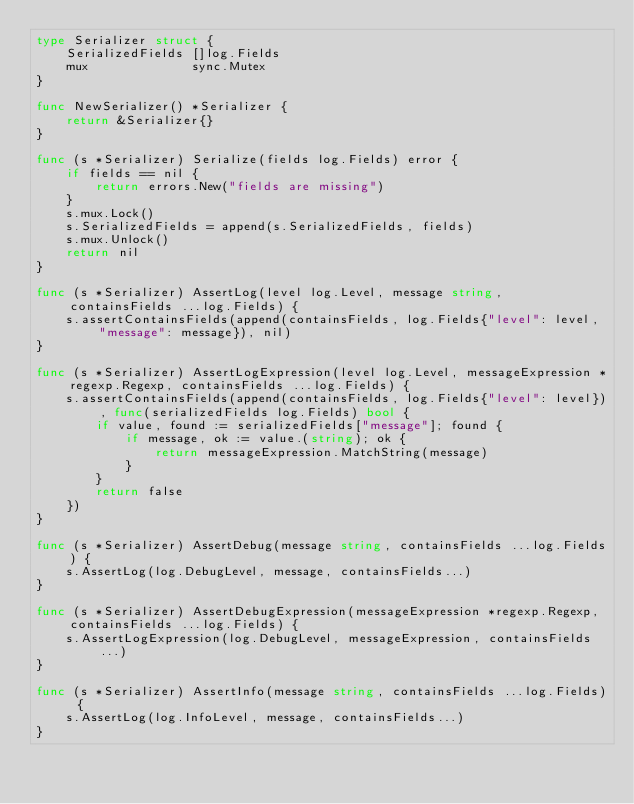Convert code to text. <code><loc_0><loc_0><loc_500><loc_500><_Go_>type Serializer struct {
	SerializedFields []log.Fields
	mux              sync.Mutex
}

func NewSerializer() *Serializer {
	return &Serializer{}
}

func (s *Serializer) Serialize(fields log.Fields) error {
	if fields == nil {
		return errors.New("fields are missing")
	}
	s.mux.Lock()
	s.SerializedFields = append(s.SerializedFields, fields)
	s.mux.Unlock()
	return nil
}

func (s *Serializer) AssertLog(level log.Level, message string, containsFields ...log.Fields) {
	s.assertContainsFields(append(containsFields, log.Fields{"level": level, "message": message}), nil)
}

func (s *Serializer) AssertLogExpression(level log.Level, messageExpression *regexp.Regexp, containsFields ...log.Fields) {
	s.assertContainsFields(append(containsFields, log.Fields{"level": level}), func(serializedFields log.Fields) bool {
		if value, found := serializedFields["message"]; found {
			if message, ok := value.(string); ok {
				return messageExpression.MatchString(message)
			}
		}
		return false
	})
}

func (s *Serializer) AssertDebug(message string, containsFields ...log.Fields) {
	s.AssertLog(log.DebugLevel, message, containsFields...)
}

func (s *Serializer) AssertDebugExpression(messageExpression *regexp.Regexp, containsFields ...log.Fields) {
	s.AssertLogExpression(log.DebugLevel, messageExpression, containsFields...)
}

func (s *Serializer) AssertInfo(message string, containsFields ...log.Fields) {
	s.AssertLog(log.InfoLevel, message, containsFields...)
}
</code> 